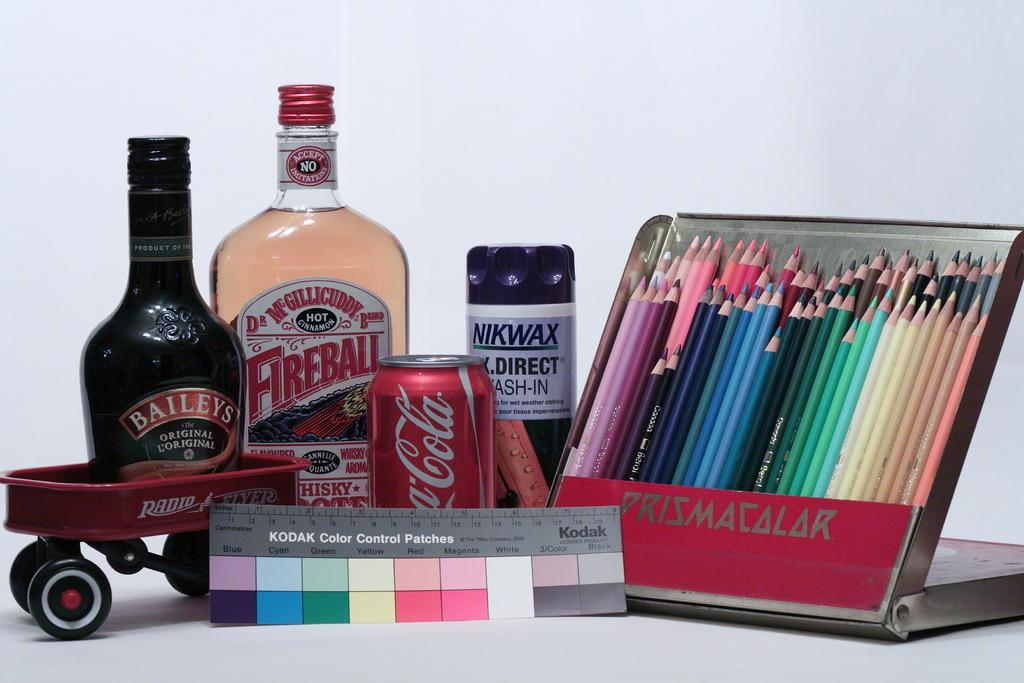Provide a one-sentence caption for the provided image. A Kodak Color Control Patch sits in front of an assortment of brand name items. 